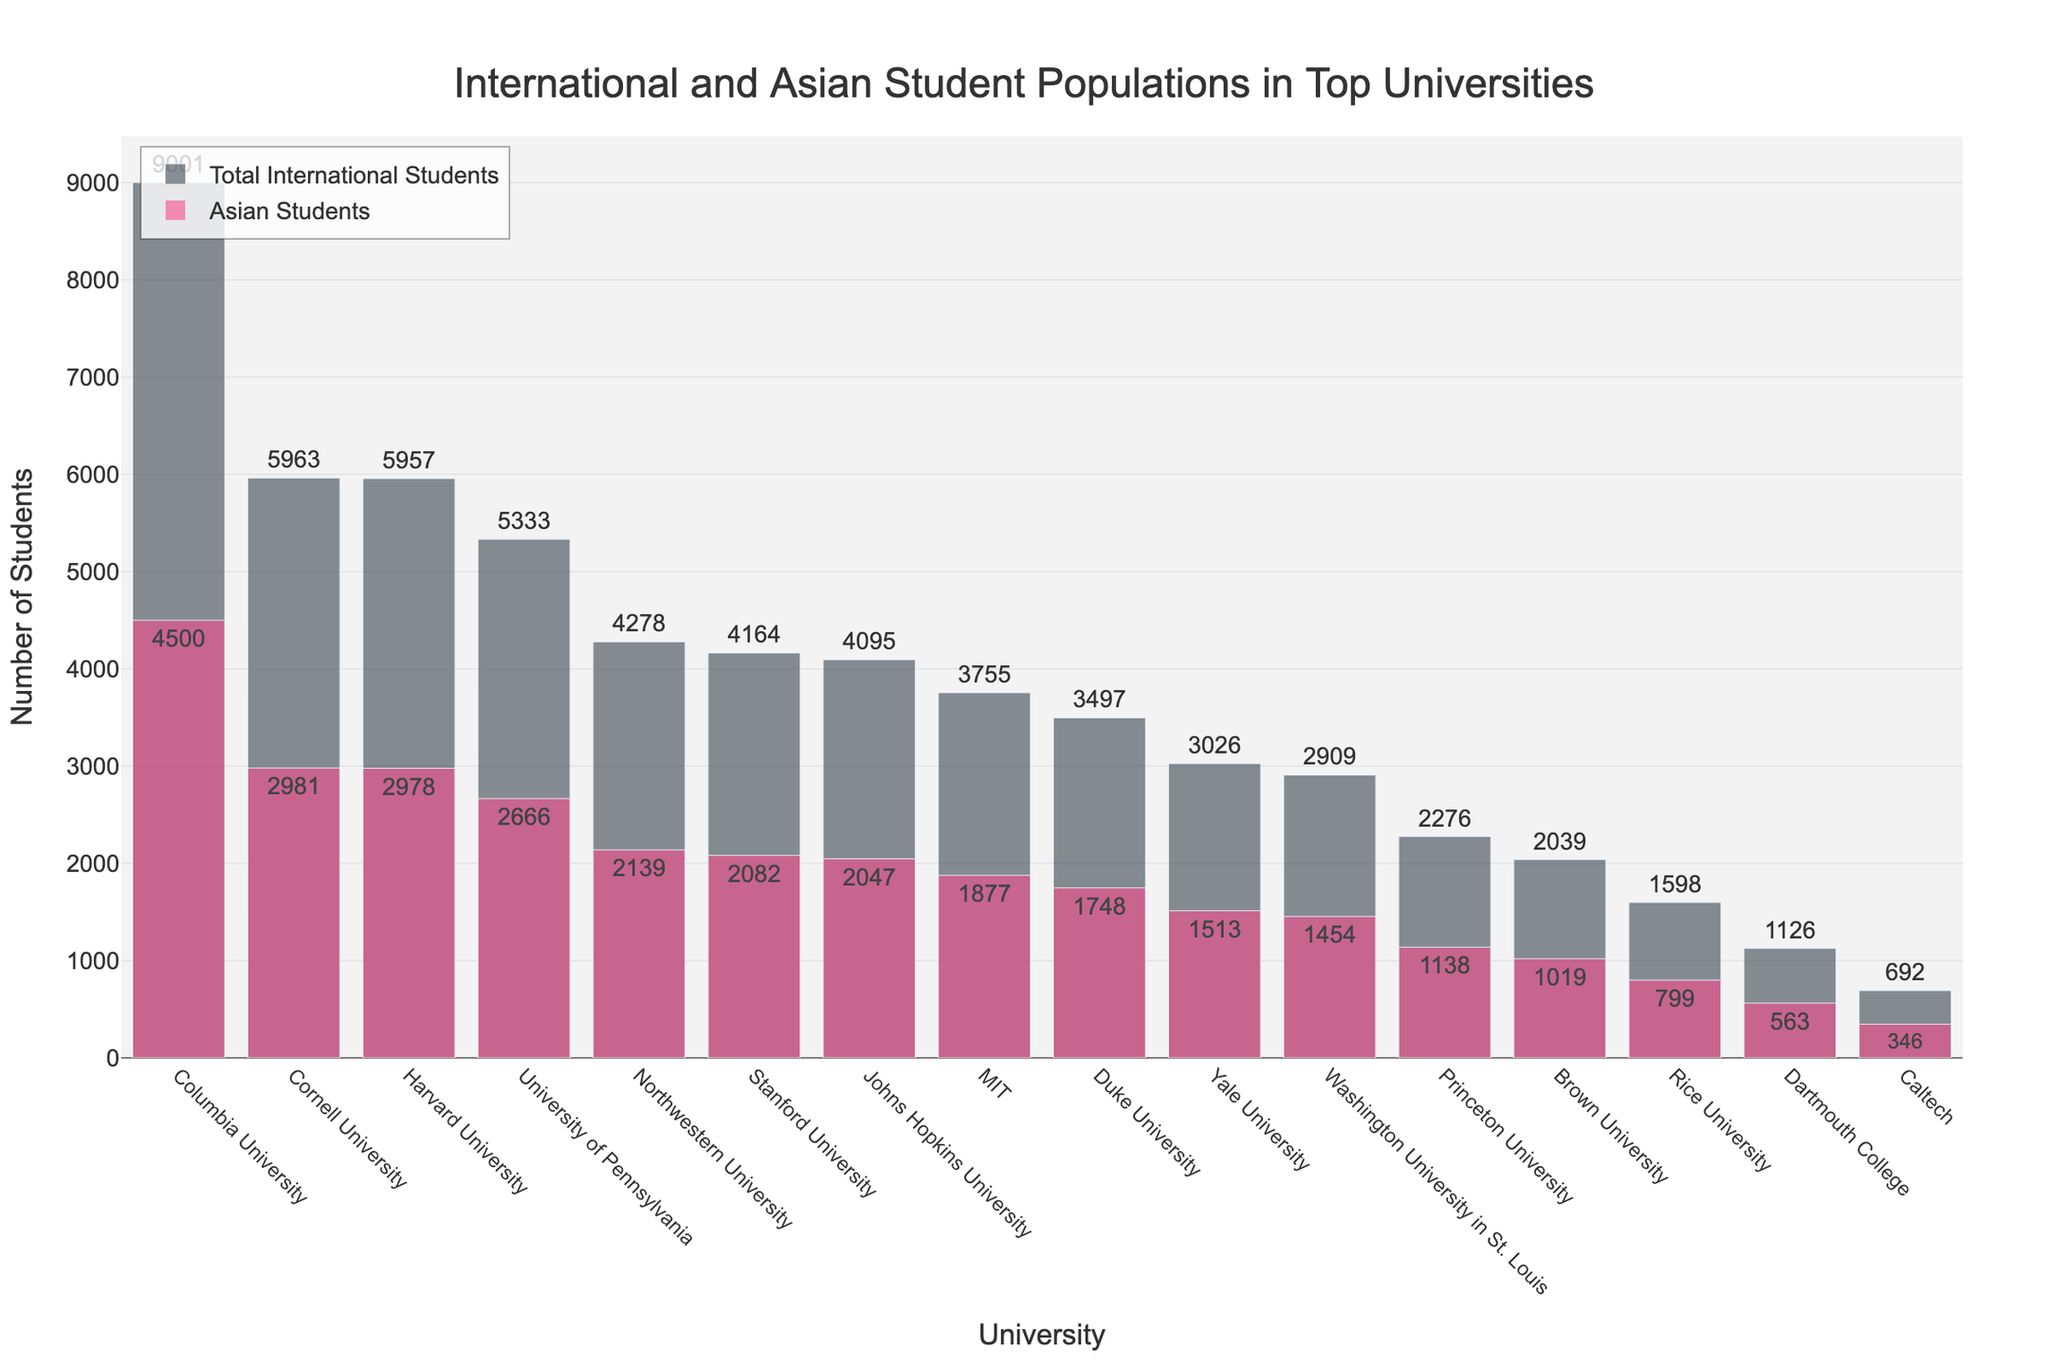What is the total number of international students at Cornell University? According to the bar chart, the total number of international students at Cornell University is noted next to the corresponding bar.
Answer: 5963 Which university has the highest number of Asian students? By comparing the heights of the bars specific to Asian students, Columbia University has the highest bar indicating it has the most Asian students.
Answer: Columbia University How many more Asian students are there at Stanford University compared to Rice University? The difference in Asian students is the height difference between the bars for Stanford University and Rice University. Stanford has 2082 Asian students, while Rice has 799. So, you subtract the smaller number from the larger one: 2082 - 799 = 1283.
Answer: 1283 Which university has the smallest population of international students? The shortest bar for total international students indicates Dartmouth College has the smallest population.
Answer: Dartmouth College What is the proportion of Asian students to total international students at Princeton University? The bar chart shows Princeton having 1138 Asian students and 2276 total international students. The proportion is 1138 / 2276.
Answer: 0.5 Compare the number of total international students at Columbia University and Harvard University. Which one has more? Referring to the bar heights, Columbia University has a taller bar indicating more international students compared to Harvard University.
Answer: Columbia University has more What is the total number of Asian students in the Ivy League schools (Columns: Harvard, Yale, Princeton, Columbia, Brown, UPenn, Dartmouth, Cornell)? Sum the Asian student counts from the Ivy League schools: 2978 (Harvard) + 1513 (Yale) + 1138 (Princeton) + 4500 (Columbia) + 1019 (Brown) + 2666 (UPenn) + 563 (Dartmouth) + 2981 (Cornell) = 17358
Answer: 17358 Among the universities listed, which school has the closest number of Asian students to Caltech? By comparing the bars for Asian students closest in height to Caltech's 346 Asian students bar, Dartmouth College has 563 Asian students, which is closest.
Answer: Dartmouth College Is the number of Asian students more than half the total international student population at MIT? According to the chart, MIT has 1877 Asian students and 3755 total international students. 1877 / 3755 = 0.5, so it equals half.
Answer: Yes Which universities have their Asian student population exactly half of their total international student population? By examining the proportions visually and validating, Harvard, Yale, Princeton, Columbia, Brown, UPenn, Dartmouth, and Cornell can be seen with their Asian population precisely half their total international population.
Answer: Harvard, Yale, Princeton, Columbia, Brown, UPenn, Dartmouth, Cornell 